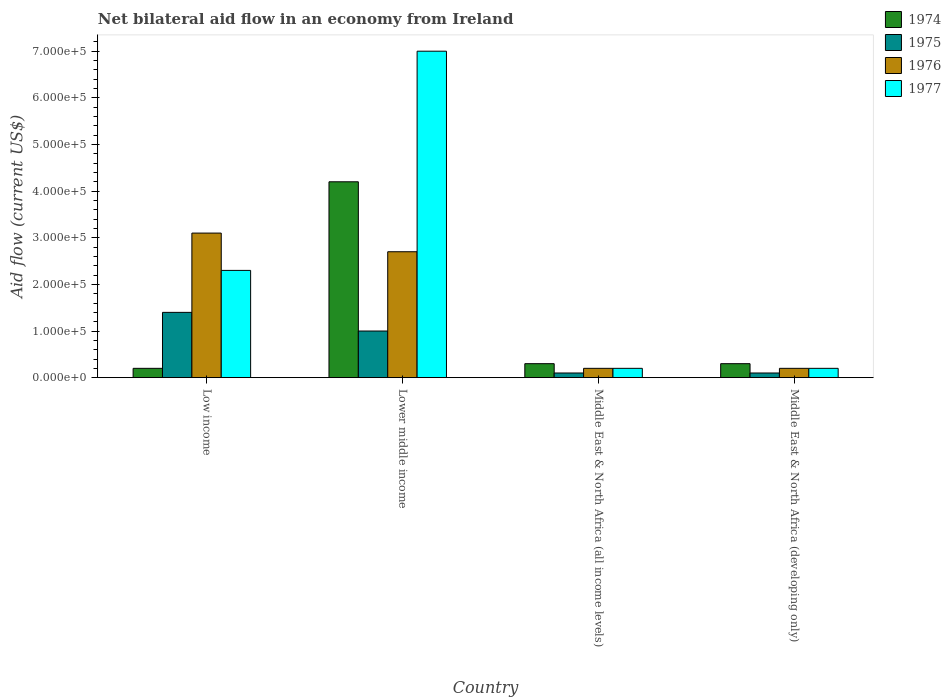How many different coloured bars are there?
Your answer should be compact. 4. How many bars are there on the 4th tick from the left?
Your response must be concise. 4. How many bars are there on the 4th tick from the right?
Keep it short and to the point. 4. What is the label of the 1st group of bars from the left?
Your answer should be compact. Low income. Across all countries, what is the maximum net bilateral aid flow in 1974?
Keep it short and to the point. 4.20e+05. Across all countries, what is the minimum net bilateral aid flow in 1974?
Provide a short and direct response. 2.00e+04. In which country was the net bilateral aid flow in 1975 maximum?
Provide a succinct answer. Low income. In which country was the net bilateral aid flow in 1977 minimum?
Your answer should be very brief. Middle East & North Africa (all income levels). What is the total net bilateral aid flow in 1976 in the graph?
Your answer should be compact. 6.20e+05. What is the difference between the net bilateral aid flow in 1974 in Low income and that in Lower middle income?
Your answer should be very brief. -4.00e+05. What is the difference between the net bilateral aid flow in 1975 in Low income and the net bilateral aid flow in 1974 in Middle East & North Africa (all income levels)?
Offer a very short reply. 1.10e+05. What is the average net bilateral aid flow in 1976 per country?
Offer a terse response. 1.55e+05. What is the difference between the net bilateral aid flow of/in 1977 and net bilateral aid flow of/in 1975 in Middle East & North Africa (developing only)?
Offer a terse response. 10000. In how many countries, is the net bilateral aid flow in 1974 greater than 340000 US$?
Offer a terse response. 1. Is the net bilateral aid flow in 1976 in Lower middle income less than that in Middle East & North Africa (developing only)?
Offer a terse response. No. Is the difference between the net bilateral aid flow in 1977 in Lower middle income and Middle East & North Africa (all income levels) greater than the difference between the net bilateral aid flow in 1975 in Lower middle income and Middle East & North Africa (all income levels)?
Your response must be concise. Yes. Is the sum of the net bilateral aid flow in 1975 in Low income and Lower middle income greater than the maximum net bilateral aid flow in 1974 across all countries?
Provide a short and direct response. No. What does the 3rd bar from the left in Middle East & North Africa (all income levels) represents?
Provide a short and direct response. 1976. What does the 3rd bar from the right in Middle East & North Africa (developing only) represents?
Keep it short and to the point. 1975. Is it the case that in every country, the sum of the net bilateral aid flow in 1976 and net bilateral aid flow in 1974 is greater than the net bilateral aid flow in 1977?
Provide a short and direct response. No. How many bars are there?
Keep it short and to the point. 16. Are all the bars in the graph horizontal?
Provide a short and direct response. No. How many countries are there in the graph?
Your response must be concise. 4. Does the graph contain any zero values?
Ensure brevity in your answer.  No. Does the graph contain grids?
Keep it short and to the point. No. How are the legend labels stacked?
Provide a short and direct response. Vertical. What is the title of the graph?
Offer a terse response. Net bilateral aid flow in an economy from Ireland. What is the label or title of the Y-axis?
Give a very brief answer. Aid flow (current US$). What is the Aid flow (current US$) of 1974 in Low income?
Provide a succinct answer. 2.00e+04. What is the Aid flow (current US$) of 1975 in Low income?
Provide a short and direct response. 1.40e+05. What is the Aid flow (current US$) of 1976 in Low income?
Provide a short and direct response. 3.10e+05. What is the Aid flow (current US$) in 1977 in Low income?
Offer a terse response. 2.30e+05. What is the Aid flow (current US$) in 1976 in Lower middle income?
Your answer should be compact. 2.70e+05. What is the Aid flow (current US$) of 1975 in Middle East & North Africa (developing only)?
Keep it short and to the point. 10000. What is the Aid flow (current US$) of 1977 in Middle East & North Africa (developing only)?
Your response must be concise. 2.00e+04. Across all countries, what is the maximum Aid flow (current US$) of 1974?
Provide a short and direct response. 4.20e+05. Across all countries, what is the maximum Aid flow (current US$) in 1975?
Your answer should be compact. 1.40e+05. Across all countries, what is the maximum Aid flow (current US$) in 1976?
Your answer should be compact. 3.10e+05. Across all countries, what is the maximum Aid flow (current US$) of 1977?
Provide a succinct answer. 7.00e+05. Across all countries, what is the minimum Aid flow (current US$) in 1974?
Offer a very short reply. 2.00e+04. Across all countries, what is the minimum Aid flow (current US$) in 1976?
Your response must be concise. 2.00e+04. Across all countries, what is the minimum Aid flow (current US$) of 1977?
Make the answer very short. 2.00e+04. What is the total Aid flow (current US$) of 1974 in the graph?
Offer a terse response. 5.00e+05. What is the total Aid flow (current US$) of 1976 in the graph?
Make the answer very short. 6.20e+05. What is the total Aid flow (current US$) of 1977 in the graph?
Offer a terse response. 9.70e+05. What is the difference between the Aid flow (current US$) in 1974 in Low income and that in Lower middle income?
Provide a short and direct response. -4.00e+05. What is the difference between the Aid flow (current US$) in 1975 in Low income and that in Lower middle income?
Give a very brief answer. 4.00e+04. What is the difference between the Aid flow (current US$) of 1976 in Low income and that in Lower middle income?
Offer a very short reply. 4.00e+04. What is the difference between the Aid flow (current US$) in 1977 in Low income and that in Lower middle income?
Give a very brief answer. -4.70e+05. What is the difference between the Aid flow (current US$) of 1975 in Low income and that in Middle East & North Africa (all income levels)?
Provide a succinct answer. 1.30e+05. What is the difference between the Aid flow (current US$) in 1976 in Low income and that in Middle East & North Africa (all income levels)?
Your answer should be compact. 2.90e+05. What is the difference between the Aid flow (current US$) of 1977 in Low income and that in Middle East & North Africa (all income levels)?
Keep it short and to the point. 2.10e+05. What is the difference between the Aid flow (current US$) in 1976 in Low income and that in Middle East & North Africa (developing only)?
Provide a short and direct response. 2.90e+05. What is the difference between the Aid flow (current US$) of 1976 in Lower middle income and that in Middle East & North Africa (all income levels)?
Make the answer very short. 2.50e+05. What is the difference between the Aid flow (current US$) in 1977 in Lower middle income and that in Middle East & North Africa (all income levels)?
Offer a very short reply. 6.80e+05. What is the difference between the Aid flow (current US$) in 1977 in Lower middle income and that in Middle East & North Africa (developing only)?
Give a very brief answer. 6.80e+05. What is the difference between the Aid flow (current US$) of 1975 in Middle East & North Africa (all income levels) and that in Middle East & North Africa (developing only)?
Provide a short and direct response. 0. What is the difference between the Aid flow (current US$) in 1977 in Middle East & North Africa (all income levels) and that in Middle East & North Africa (developing only)?
Give a very brief answer. 0. What is the difference between the Aid flow (current US$) of 1974 in Low income and the Aid flow (current US$) of 1975 in Lower middle income?
Provide a succinct answer. -8.00e+04. What is the difference between the Aid flow (current US$) of 1974 in Low income and the Aid flow (current US$) of 1976 in Lower middle income?
Your response must be concise. -2.50e+05. What is the difference between the Aid flow (current US$) in 1974 in Low income and the Aid flow (current US$) in 1977 in Lower middle income?
Ensure brevity in your answer.  -6.80e+05. What is the difference between the Aid flow (current US$) of 1975 in Low income and the Aid flow (current US$) of 1977 in Lower middle income?
Your answer should be very brief. -5.60e+05. What is the difference between the Aid flow (current US$) of 1976 in Low income and the Aid flow (current US$) of 1977 in Lower middle income?
Your answer should be very brief. -3.90e+05. What is the difference between the Aid flow (current US$) in 1974 in Low income and the Aid flow (current US$) in 1975 in Middle East & North Africa (all income levels)?
Offer a very short reply. 10000. What is the difference between the Aid flow (current US$) in 1974 in Low income and the Aid flow (current US$) in 1977 in Middle East & North Africa (all income levels)?
Your answer should be very brief. 0. What is the difference between the Aid flow (current US$) in 1975 in Low income and the Aid flow (current US$) in 1977 in Middle East & North Africa (all income levels)?
Your answer should be very brief. 1.20e+05. What is the difference between the Aid flow (current US$) of 1976 in Low income and the Aid flow (current US$) of 1977 in Middle East & North Africa (all income levels)?
Provide a short and direct response. 2.90e+05. What is the difference between the Aid flow (current US$) in 1974 in Low income and the Aid flow (current US$) in 1975 in Middle East & North Africa (developing only)?
Your answer should be compact. 10000. What is the difference between the Aid flow (current US$) in 1974 in Low income and the Aid flow (current US$) in 1976 in Middle East & North Africa (developing only)?
Offer a terse response. 0. What is the difference between the Aid flow (current US$) in 1974 in Low income and the Aid flow (current US$) in 1977 in Middle East & North Africa (developing only)?
Keep it short and to the point. 0. What is the difference between the Aid flow (current US$) of 1974 in Lower middle income and the Aid flow (current US$) of 1977 in Middle East & North Africa (all income levels)?
Give a very brief answer. 4.00e+05. What is the difference between the Aid flow (current US$) of 1975 in Lower middle income and the Aid flow (current US$) of 1977 in Middle East & North Africa (all income levels)?
Your answer should be very brief. 8.00e+04. What is the difference between the Aid flow (current US$) in 1976 in Lower middle income and the Aid flow (current US$) in 1977 in Middle East & North Africa (all income levels)?
Provide a short and direct response. 2.50e+05. What is the difference between the Aid flow (current US$) of 1974 in Lower middle income and the Aid flow (current US$) of 1975 in Middle East & North Africa (developing only)?
Your answer should be very brief. 4.10e+05. What is the difference between the Aid flow (current US$) in 1975 in Lower middle income and the Aid flow (current US$) in 1976 in Middle East & North Africa (developing only)?
Offer a very short reply. 8.00e+04. What is the difference between the Aid flow (current US$) of 1976 in Lower middle income and the Aid flow (current US$) of 1977 in Middle East & North Africa (developing only)?
Provide a short and direct response. 2.50e+05. What is the difference between the Aid flow (current US$) of 1974 in Middle East & North Africa (all income levels) and the Aid flow (current US$) of 1975 in Middle East & North Africa (developing only)?
Your answer should be compact. 2.00e+04. What is the difference between the Aid flow (current US$) in 1974 in Middle East & North Africa (all income levels) and the Aid flow (current US$) in 1977 in Middle East & North Africa (developing only)?
Provide a succinct answer. 10000. What is the difference between the Aid flow (current US$) of 1975 in Middle East & North Africa (all income levels) and the Aid flow (current US$) of 1976 in Middle East & North Africa (developing only)?
Provide a succinct answer. -10000. What is the difference between the Aid flow (current US$) in 1976 in Middle East & North Africa (all income levels) and the Aid flow (current US$) in 1977 in Middle East & North Africa (developing only)?
Ensure brevity in your answer.  0. What is the average Aid flow (current US$) of 1974 per country?
Provide a short and direct response. 1.25e+05. What is the average Aid flow (current US$) in 1975 per country?
Provide a short and direct response. 6.50e+04. What is the average Aid flow (current US$) in 1976 per country?
Your answer should be compact. 1.55e+05. What is the average Aid flow (current US$) in 1977 per country?
Your answer should be very brief. 2.42e+05. What is the difference between the Aid flow (current US$) in 1976 and Aid flow (current US$) in 1977 in Low income?
Provide a short and direct response. 8.00e+04. What is the difference between the Aid flow (current US$) in 1974 and Aid flow (current US$) in 1975 in Lower middle income?
Give a very brief answer. 3.20e+05. What is the difference between the Aid flow (current US$) in 1974 and Aid flow (current US$) in 1977 in Lower middle income?
Offer a terse response. -2.80e+05. What is the difference between the Aid flow (current US$) in 1975 and Aid flow (current US$) in 1976 in Lower middle income?
Ensure brevity in your answer.  -1.70e+05. What is the difference between the Aid flow (current US$) of 1975 and Aid flow (current US$) of 1977 in Lower middle income?
Keep it short and to the point. -6.00e+05. What is the difference between the Aid flow (current US$) of 1976 and Aid flow (current US$) of 1977 in Lower middle income?
Make the answer very short. -4.30e+05. What is the difference between the Aid flow (current US$) of 1974 and Aid flow (current US$) of 1976 in Middle East & North Africa (all income levels)?
Your answer should be very brief. 10000. What is the difference between the Aid flow (current US$) of 1974 and Aid flow (current US$) of 1977 in Middle East & North Africa (all income levels)?
Your response must be concise. 10000. What is the difference between the Aid flow (current US$) in 1976 and Aid flow (current US$) in 1977 in Middle East & North Africa (all income levels)?
Your answer should be compact. 0. What is the difference between the Aid flow (current US$) in 1974 and Aid flow (current US$) in 1976 in Middle East & North Africa (developing only)?
Your answer should be compact. 10000. What is the difference between the Aid flow (current US$) of 1974 and Aid flow (current US$) of 1977 in Middle East & North Africa (developing only)?
Keep it short and to the point. 10000. What is the difference between the Aid flow (current US$) in 1975 and Aid flow (current US$) in 1977 in Middle East & North Africa (developing only)?
Offer a very short reply. -10000. What is the ratio of the Aid flow (current US$) in 1974 in Low income to that in Lower middle income?
Your answer should be very brief. 0.05. What is the ratio of the Aid flow (current US$) in 1976 in Low income to that in Lower middle income?
Offer a very short reply. 1.15. What is the ratio of the Aid flow (current US$) in 1977 in Low income to that in Lower middle income?
Offer a terse response. 0.33. What is the ratio of the Aid flow (current US$) in 1974 in Low income to that in Middle East & North Africa (all income levels)?
Offer a very short reply. 0.67. What is the ratio of the Aid flow (current US$) in 1976 in Low income to that in Middle East & North Africa (all income levels)?
Your response must be concise. 15.5. What is the ratio of the Aid flow (current US$) of 1977 in Low income to that in Middle East & North Africa (all income levels)?
Give a very brief answer. 11.5. What is the ratio of the Aid flow (current US$) in 1976 in Low income to that in Middle East & North Africa (developing only)?
Offer a terse response. 15.5. What is the ratio of the Aid flow (current US$) of 1974 in Lower middle income to that in Middle East & North Africa (all income levels)?
Provide a short and direct response. 14. What is the ratio of the Aid flow (current US$) in 1975 in Lower middle income to that in Middle East & North Africa (all income levels)?
Keep it short and to the point. 10. What is the ratio of the Aid flow (current US$) in 1977 in Lower middle income to that in Middle East & North Africa (all income levels)?
Provide a short and direct response. 35. What is the ratio of the Aid flow (current US$) of 1976 in Lower middle income to that in Middle East & North Africa (developing only)?
Make the answer very short. 13.5. What is the difference between the highest and the second highest Aid flow (current US$) of 1975?
Your answer should be compact. 4.00e+04. What is the difference between the highest and the second highest Aid flow (current US$) in 1976?
Offer a terse response. 4.00e+04. What is the difference between the highest and the lowest Aid flow (current US$) of 1974?
Your answer should be very brief. 4.00e+05. What is the difference between the highest and the lowest Aid flow (current US$) in 1976?
Offer a very short reply. 2.90e+05. What is the difference between the highest and the lowest Aid flow (current US$) of 1977?
Offer a very short reply. 6.80e+05. 